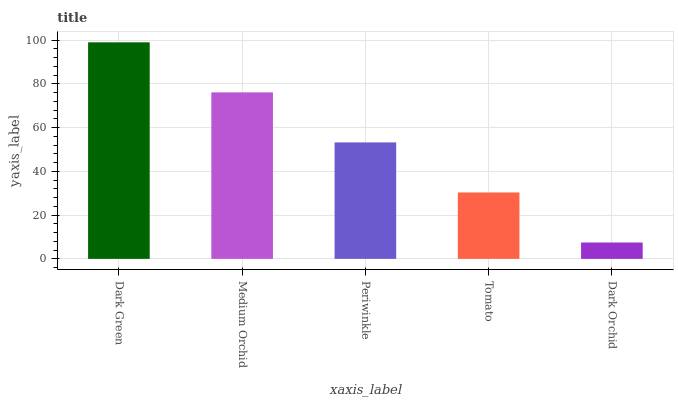Is Dark Orchid the minimum?
Answer yes or no. Yes. Is Dark Green the maximum?
Answer yes or no. Yes. Is Medium Orchid the minimum?
Answer yes or no. No. Is Medium Orchid the maximum?
Answer yes or no. No. Is Dark Green greater than Medium Orchid?
Answer yes or no. Yes. Is Medium Orchid less than Dark Green?
Answer yes or no. Yes. Is Medium Orchid greater than Dark Green?
Answer yes or no. No. Is Dark Green less than Medium Orchid?
Answer yes or no. No. Is Periwinkle the high median?
Answer yes or no. Yes. Is Periwinkle the low median?
Answer yes or no. Yes. Is Dark Orchid the high median?
Answer yes or no. No. Is Tomato the low median?
Answer yes or no. No. 